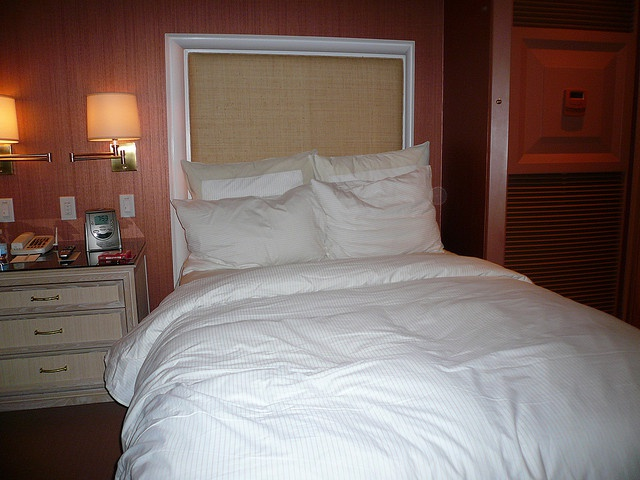Describe the objects in this image and their specific colors. I can see bed in black, darkgray, lightgray, and gray tones and clock in black, gray, darkgray, and teal tones in this image. 